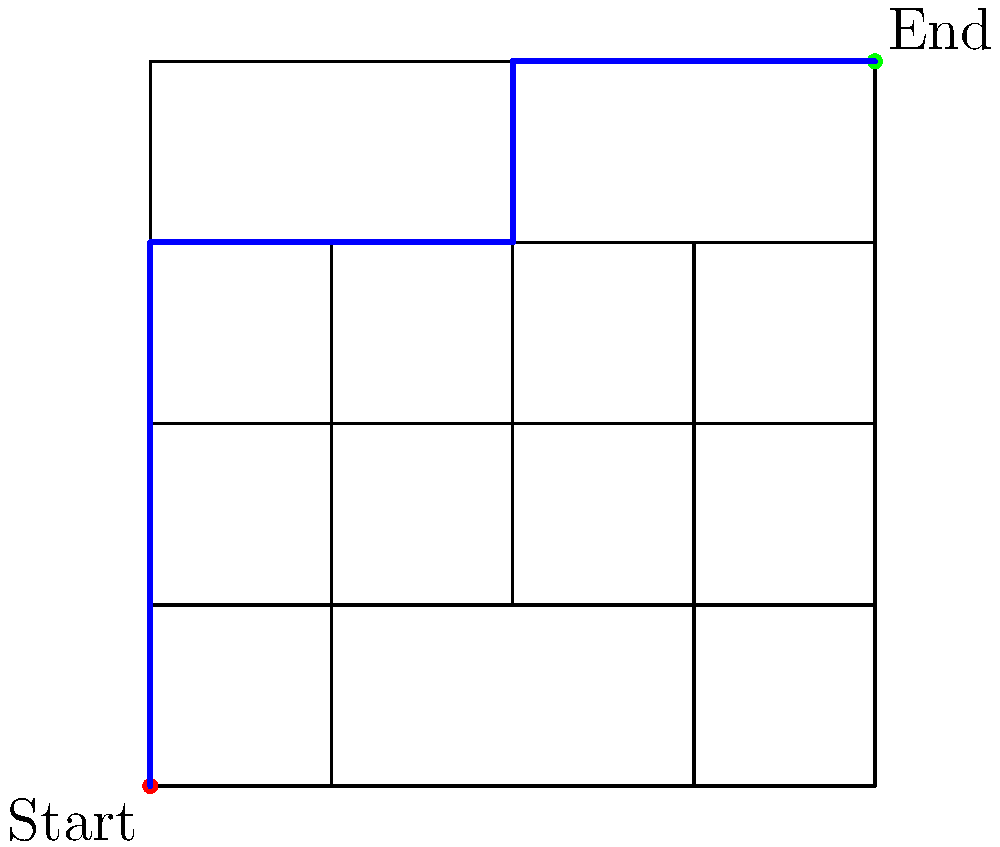In the dungeon layout shown above, which resembles the grid-based movement in Candy Box, what is the minimum number of steps required to reach the end point from the start point, assuming you can only move horizontally or vertically? To solve this problem, we'll use a method similar to pathfinding in grid-based games like Candy Box:

1. Observe that we can only move horizontally or vertically, not diagonally.
2. Start at the red dot (0,0) and count the steps to the green dot (4,4).
3. The optimal path is highlighted in blue.
4. Count the steps:
   - 3 steps up from (0,0) to (0,3)
   - 2 steps right from (0,3) to (2,3)
   - 1 step up from (2,3) to (2,4)
   - 2 steps right from (2,4) to (4,4)
5. Sum up the steps: 3 + 2 + 1 + 2 = 8

Therefore, the minimum number of steps required is 8.

This approach is similar to finding the shortest path in games like Candy Box, where efficient movement through grid-based levels is crucial for optimal gameplay.
Answer: 8 steps 